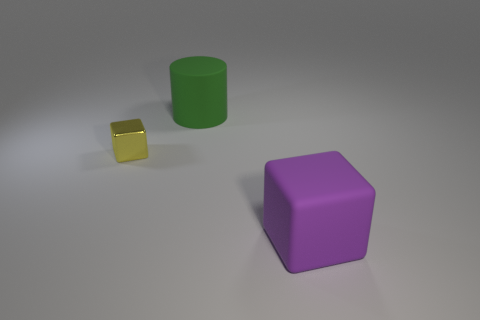Is there anything else that has the same size as the yellow thing?
Your answer should be very brief. No. Is the object to the right of the green thing made of the same material as the large thing that is behind the big rubber cube?
Your answer should be very brief. Yes. There is a thing that is in front of the shiny thing; what shape is it?
Provide a short and direct response. Cube. There is another object that is the same shape as the small thing; what size is it?
Provide a succinct answer. Large. Are there any other things that have the same shape as the purple rubber object?
Offer a very short reply. Yes. Are there any cubes on the right side of the block to the left of the matte cylinder?
Offer a very short reply. Yes. What is the color of the other metal object that is the same shape as the purple object?
Provide a succinct answer. Yellow. How many other cubes have the same color as the small block?
Your answer should be compact. 0. There is a cube to the right of the large object behind the object that is to the right of the rubber cylinder; what color is it?
Your answer should be compact. Purple. Is the material of the small yellow block the same as the green cylinder?
Give a very brief answer. No. 